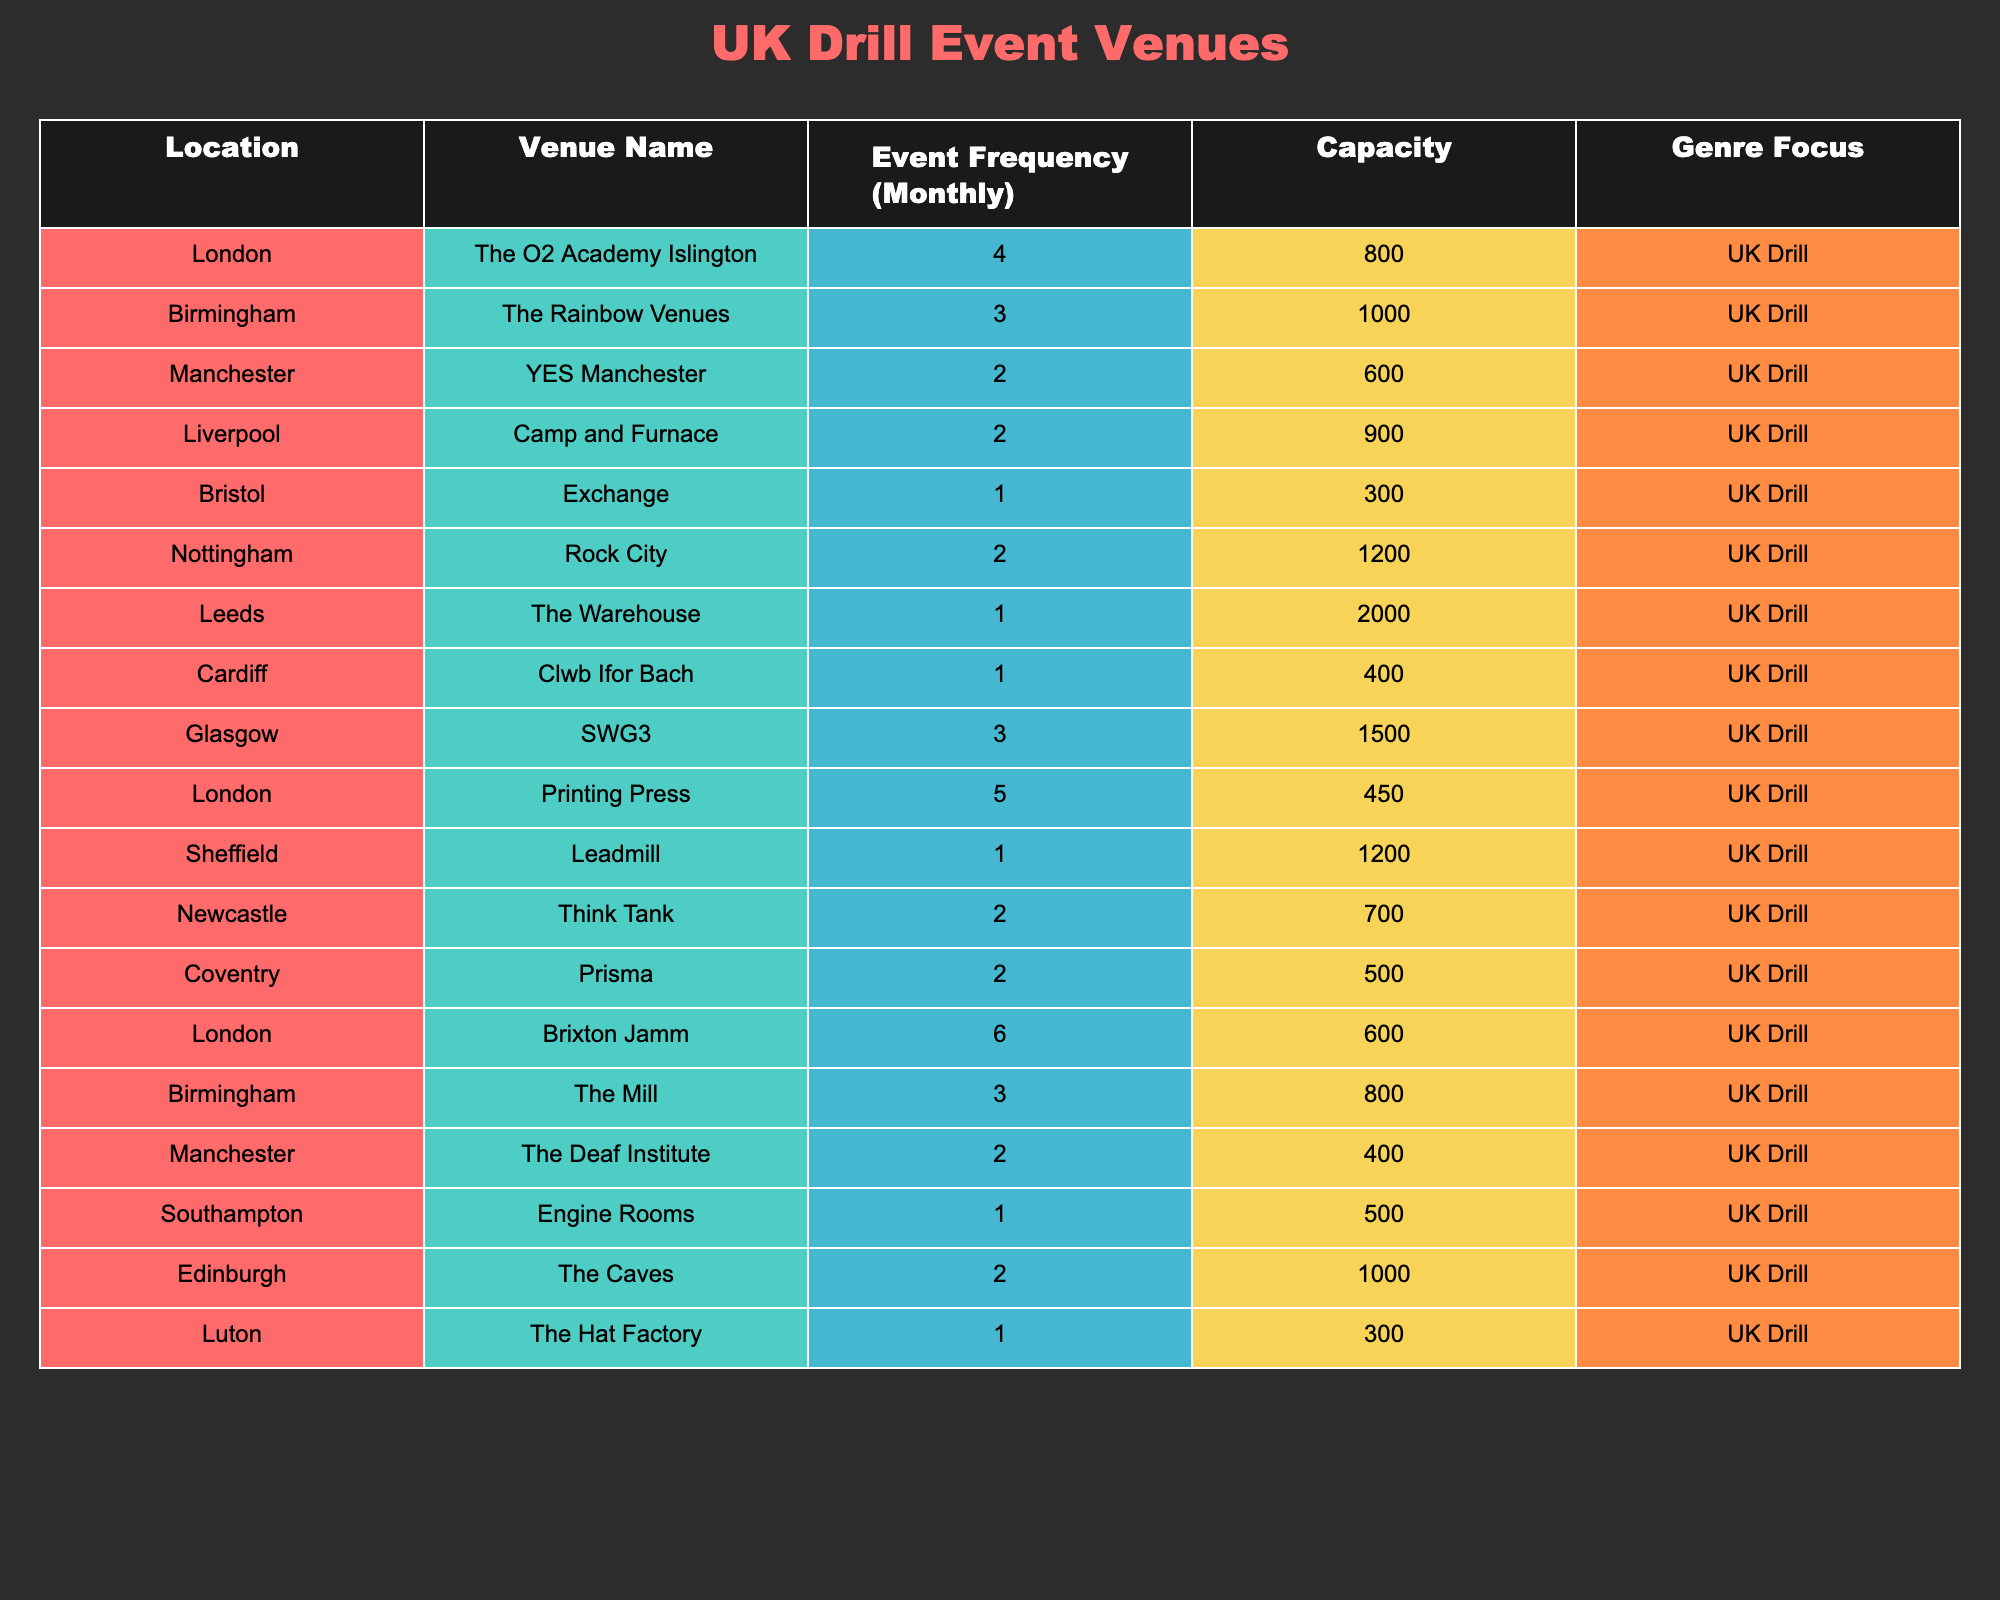What is the venue with the highest event frequency for UK drill? By examining the "Event Frequency (Monthly)" column, I found that "Brixton Jamm" has the highest frequency at 6 times a month.
Answer: Brixton Jamm Which city has the least number of venues hosting UK drill events? Looking at the table, both Bristol, Cardiff, and Luton each have only 1 venue hosting UK drill events.
Answer: Bristol, Cardiff, Luton What is the combined monthly event frequency of UK drill events in Birmingham? Birmingham has two venues: "The Rainbow Venues" (3) and "The Mill" (3). Summing these gives us 3 + 3 = 6.
Answer: 6 Is there any venue in London that hosts UK drill events more than 5 times a month? The table shows that "Brixton Jamm" (6) and "Printing Press" (5) both host events more than 5 times a month.
Answer: Yes How many venues have a capacity of over 1000 for hosting UK drill events? Checking the "Capacity" column, the venues with a capacity over 1000 are "The Rainbow Venues" (1000), "Rock City" (1200), "SWG3" (1500), and "Edinburgh" (1000) making a total of 4 venues.
Answer: 4 What is the average event frequency for venues located in London? The London venues are "The O2 Academy Islington" (4), "Printing Press" (5), and "Brixton Jamm" (6). Adding these gives 4 + 5 + 6 = 15, and dividing by 3 gives an average of 15/3 = 5.
Answer: 5 Which city has the venue with the highest capacity? The venue with the highest capacity is "The Warehouse" in Leeds with a capacity of 2000, according to the "Capacity" column.
Answer: Leeds Are there more venues in Manchester or Birmingham hosting UK drill events? Manchester has 2 venues ("YES Manchester" and "The Deaf Institute") while Birmingham has 2 venues ("The Rainbow Venues" and "The Mill"), resulting in an equal number.
Answer: Equal What venue has the second highest event frequency, and what is that frequency? After "Brixton Jamm" (6), the next highest is "Printing Press" (5). Thus, "Printing Press" has the second highest frequency at 5.
Answer: Printing Press, 5 How many cities have just one venue hosting UK drill music events? The locations with only one venue include Bristol, Cardiff, and Luton, totaling 3 cities with just one venue each.
Answer: 3 